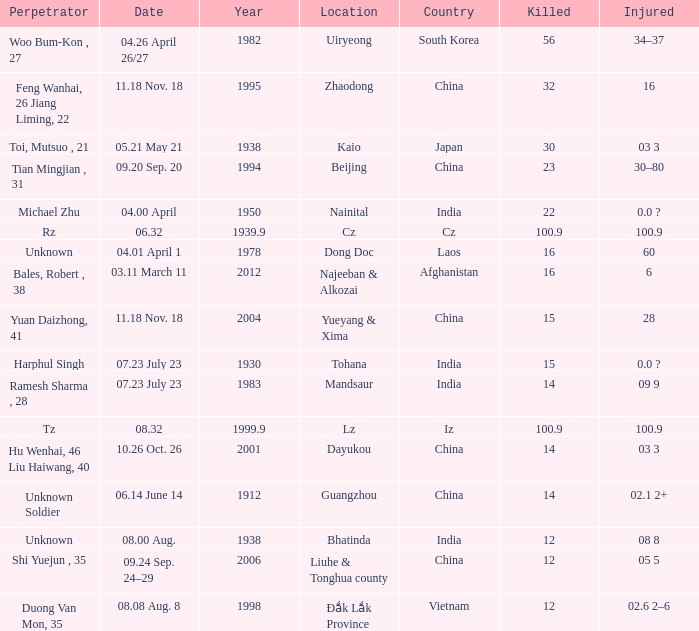For the date "04.01 april 1", what is the typical year? 1978.0. 